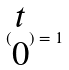<formula> <loc_0><loc_0><loc_500><loc_500>( \begin{matrix} t \\ 0 \end{matrix} ) = 1</formula> 